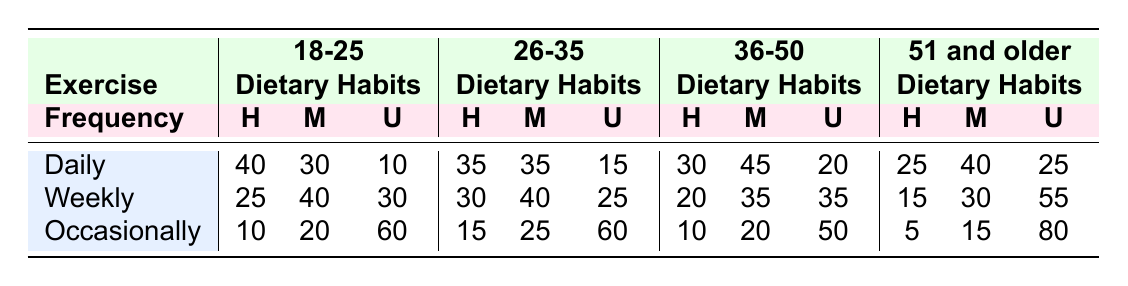What is the number of individuals aged 18-25 who exercise daily and have a healthy diet? From the table, the number of individuals aged 18-25 who have a daily exercise frequency is 40 with a healthy diet as indicated in the Daily row and Healthy Diet column.
Answer: 40 What percentage of individuals aged 26-35 exercise occasionally and follow an unhealthy diet? For the age group 26-35, the number of individuals exercising occasionally with an unhealthy diet is 60. To find the total number of individuals in that category, we add all three dietary habits (15 + 25 + 60 = 100). Then, we calculate the percentage: (60/100) * 100 = 60%.
Answer: 60% Is there a higher number of individuals aged 51 and older who exercise weekly and follow a moderately healthy diet compared to those who exercise daily and have an unhealthy diet? In the age group 51 and older, the number of individuals who exercise weekly and have a moderately healthy diet is 30, while those who exercise daily and have an unhealthy diet is 25. Therefore, 30 > 25.
Answer: Yes What is the total number of individuals aged 36-50 who have a healthy diet across all exercise frequencies? For the age group 36-50, we sum up the individuals with a healthy diet across all exercise frequencies: Daily (30) + Weekly (20) + Occasionally (10) = 60.
Answer: 60 Which age group has the highest number of individuals exercising daily and following a moderately healthy diet? Analyzing the table, for individuals exercising daily and having a moderately healthy diet, we find the following: 18-25 has 30, 26-35 has 35, 36-50 has 45, and 51 and older has 40. The age group 36-50 has the highest number at 45.
Answer: 36-50 How many more individuals in the 51 and older group have an unhealthy diet when exercising occasionally compared to the 18-25 group? For the age group 51 and older, the number of individuals with an unhealthy diet who exercise occasionally is 80. For the 18-25 group, this number is 60. To find the difference: 80 - 60 = 20.
Answer: 20 What is the average number of individuals across all age groups who follow a healthy diet and exercise weekly? We gather the numbers for each age group under the healthy diet and weekly exercise frequency: 25 (18-25) + 30 (26-35) + 20 (36-50) + 15 (51 and older) = 100, and there are 4 age groups. Thus, the average is 100/4 = 25.
Answer: 25 